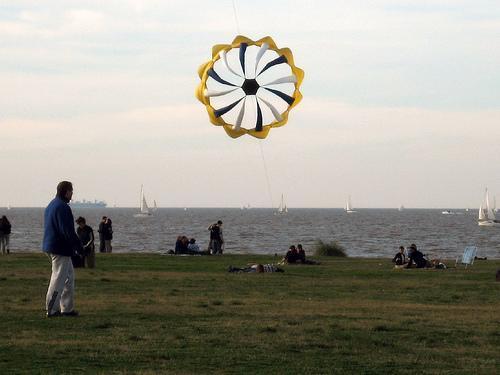How many bike on this image?
Give a very brief answer. 0. 